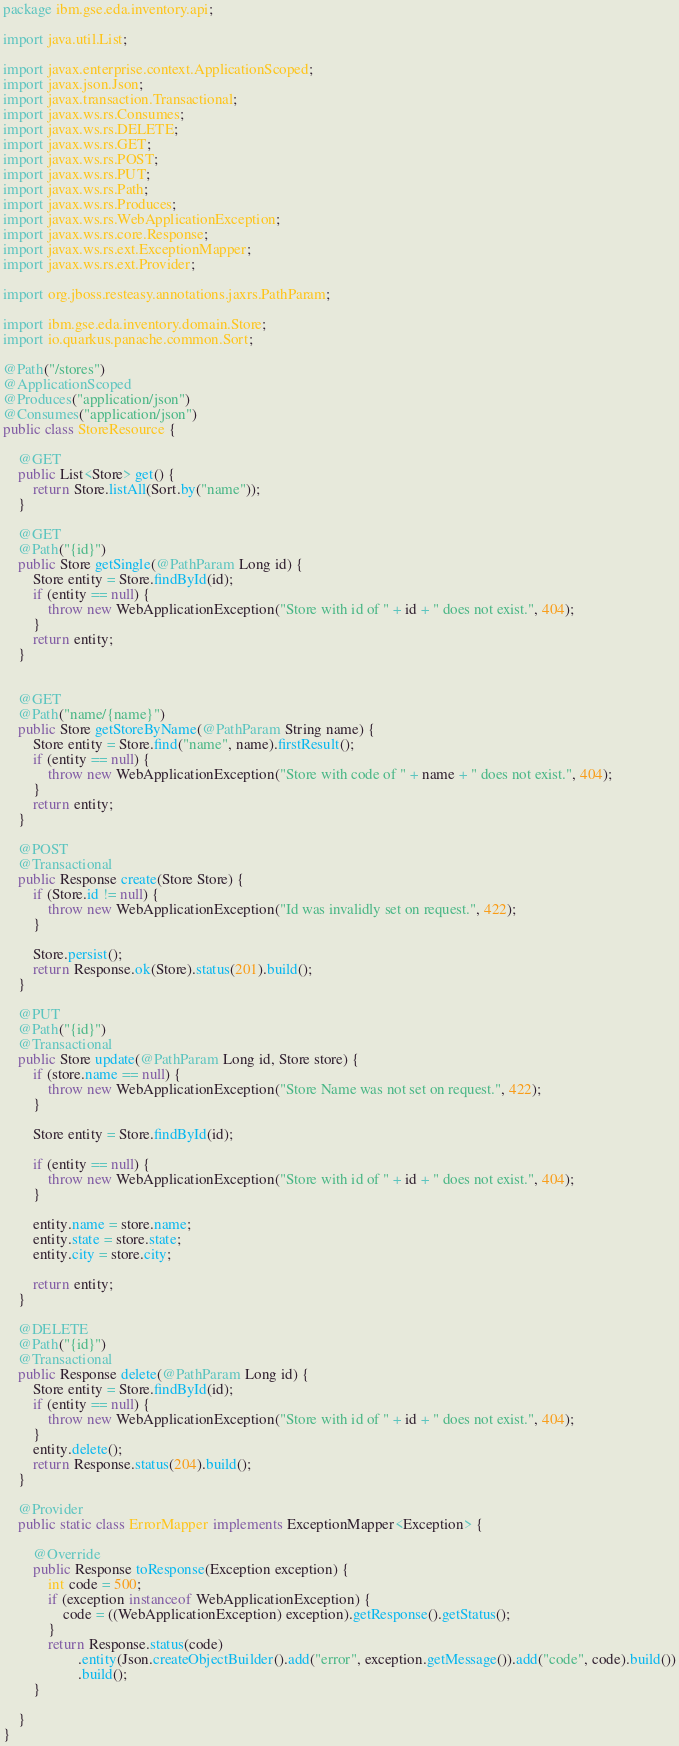<code> <loc_0><loc_0><loc_500><loc_500><_Java_>package ibm.gse.eda.inventory.api;

import java.util.List;

import javax.enterprise.context.ApplicationScoped;
import javax.json.Json;
import javax.transaction.Transactional;
import javax.ws.rs.Consumes;
import javax.ws.rs.DELETE;
import javax.ws.rs.GET;
import javax.ws.rs.POST;
import javax.ws.rs.PUT;
import javax.ws.rs.Path;
import javax.ws.rs.Produces;
import javax.ws.rs.WebApplicationException;
import javax.ws.rs.core.Response;
import javax.ws.rs.ext.ExceptionMapper;
import javax.ws.rs.ext.Provider;

import org.jboss.resteasy.annotations.jaxrs.PathParam;

import ibm.gse.eda.inventory.domain.Store;
import io.quarkus.panache.common.Sort;

@Path("/stores")
@ApplicationScoped
@Produces("application/json")
@Consumes("application/json")
public class StoreResource {

    @GET
    public List<Store> get() {
        return Store.listAll(Sort.by("name"));
    }

    @GET
    @Path("{id}")
    public Store getSingle(@PathParam Long id) {
        Store entity = Store.findById(id);
        if (entity == null) {
            throw new WebApplicationException("Store with id of " + id + " does not exist.", 404);
        }
        return entity;
    }


    @GET
    @Path("name/{name}")
    public Store getStoreByName(@PathParam String name) {
        Store entity = Store.find("name", name).firstResult();
        if (entity == null) {
            throw new WebApplicationException("Store with code of " + name + " does not exist.", 404);
        }
        return entity;
    }

    @POST
    @Transactional
    public Response create(Store Store) {
        if (Store.id != null) {
            throw new WebApplicationException("Id was invalidly set on request.", 422);
        }

        Store.persist();
        return Response.ok(Store).status(201).build();
    }

    @PUT
    @Path("{id}")
    @Transactional
    public Store update(@PathParam Long id, Store store) {
        if (store.name == null) {
            throw new WebApplicationException("Store Name was not set on request.", 422);
        }

        Store entity = Store.findById(id);

        if (entity == null) {
            throw new WebApplicationException("Store with id of " + id + " does not exist.", 404);
        }

        entity.name = store.name;
        entity.state = store.state;
        entity.city = store.city;

        return entity;
    }

    @DELETE
    @Path("{id}")
    @Transactional
    public Response delete(@PathParam Long id) {
        Store entity = Store.findById(id);
        if (entity == null) {
            throw new WebApplicationException("Store with id of " + id + " does not exist.", 404);
        }
        entity.delete();
        return Response.status(204).build();
    }

    @Provider
    public static class ErrorMapper implements ExceptionMapper<Exception> {

        @Override
        public Response toResponse(Exception exception) {
            int code = 500;
            if (exception instanceof WebApplicationException) {
                code = ((WebApplicationException) exception).getResponse().getStatus();
            }
            return Response.status(code)
                    .entity(Json.createObjectBuilder().add("error", exception.getMessage()).add("code", code).build())
                    .build();
        }

    }
}</code> 